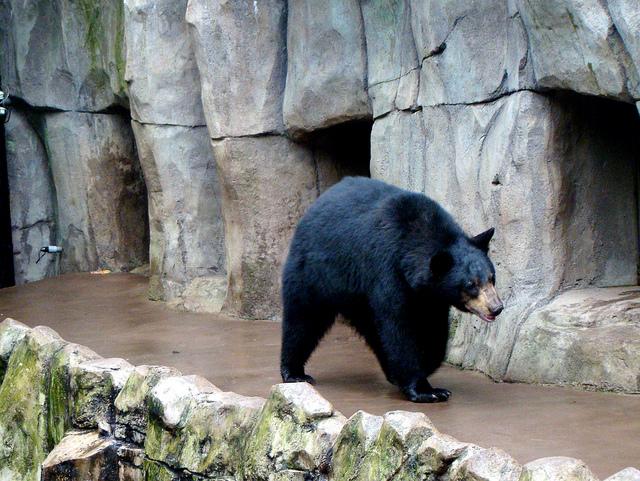Is the ground rocks or dirt?
Keep it brief. Rocks. What color is the bear's nose?
Give a very brief answer. Black. Is this natural or zoo?
Quick response, please. Zoo. 